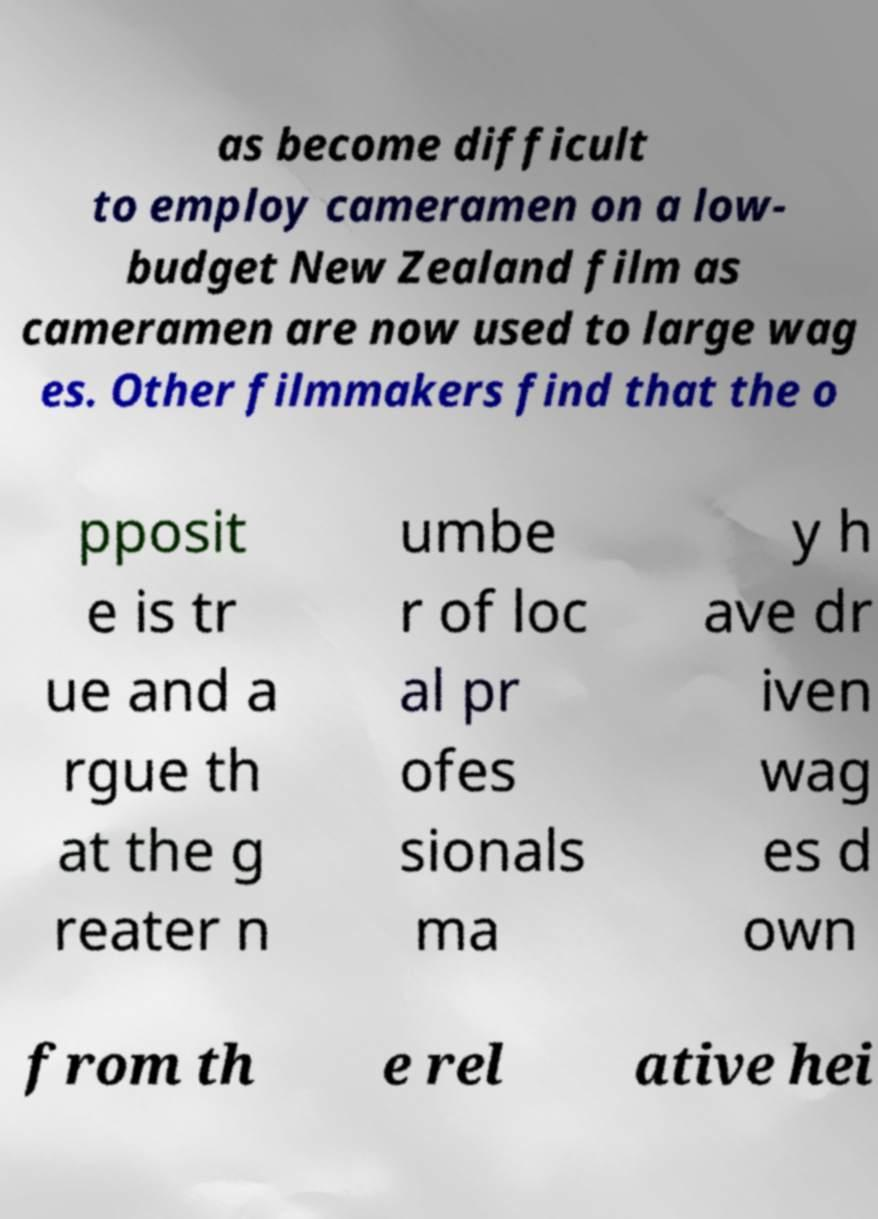Could you assist in decoding the text presented in this image and type it out clearly? as become difficult to employ cameramen on a low- budget New Zealand film as cameramen are now used to large wag es. Other filmmakers find that the o pposit e is tr ue and a rgue th at the g reater n umbe r of loc al pr ofes sionals ma y h ave dr iven wag es d own from th e rel ative hei 